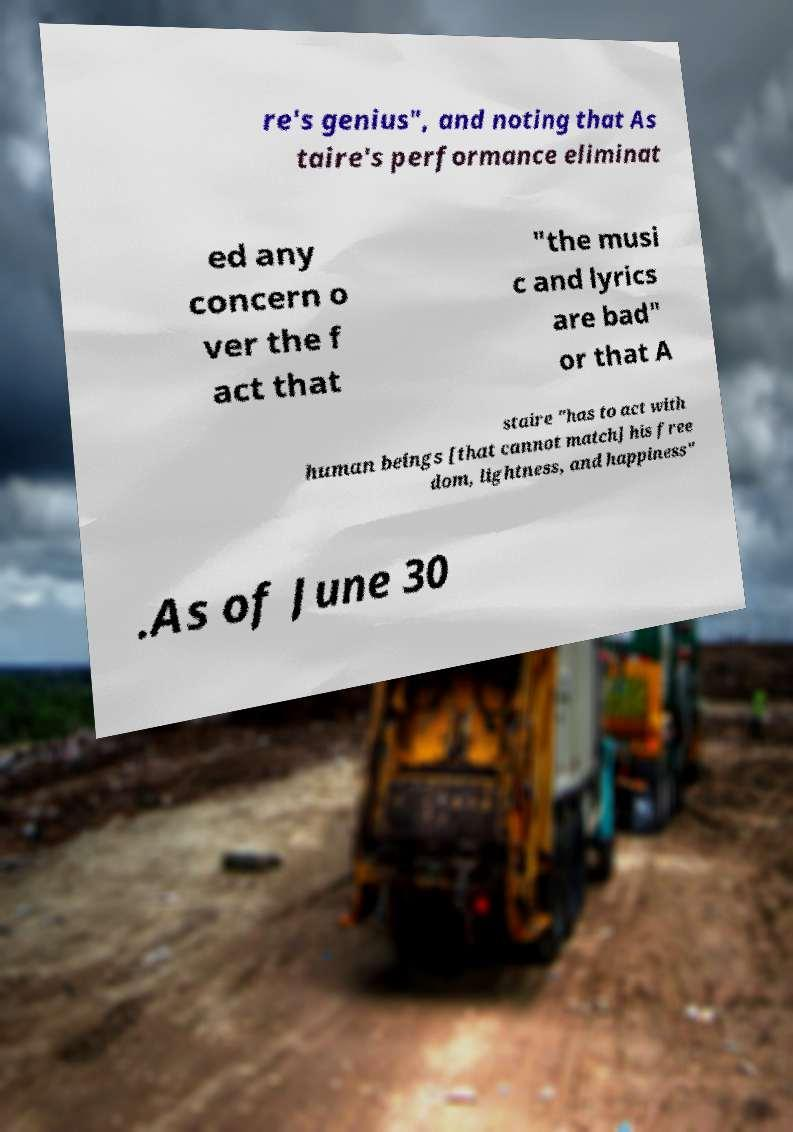What messages or text are displayed in this image? I need them in a readable, typed format. re's genius", and noting that As taire's performance eliminat ed any concern o ver the f act that "the musi c and lyrics are bad" or that A staire "has to act with human beings [that cannot match] his free dom, lightness, and happiness" .As of June 30 